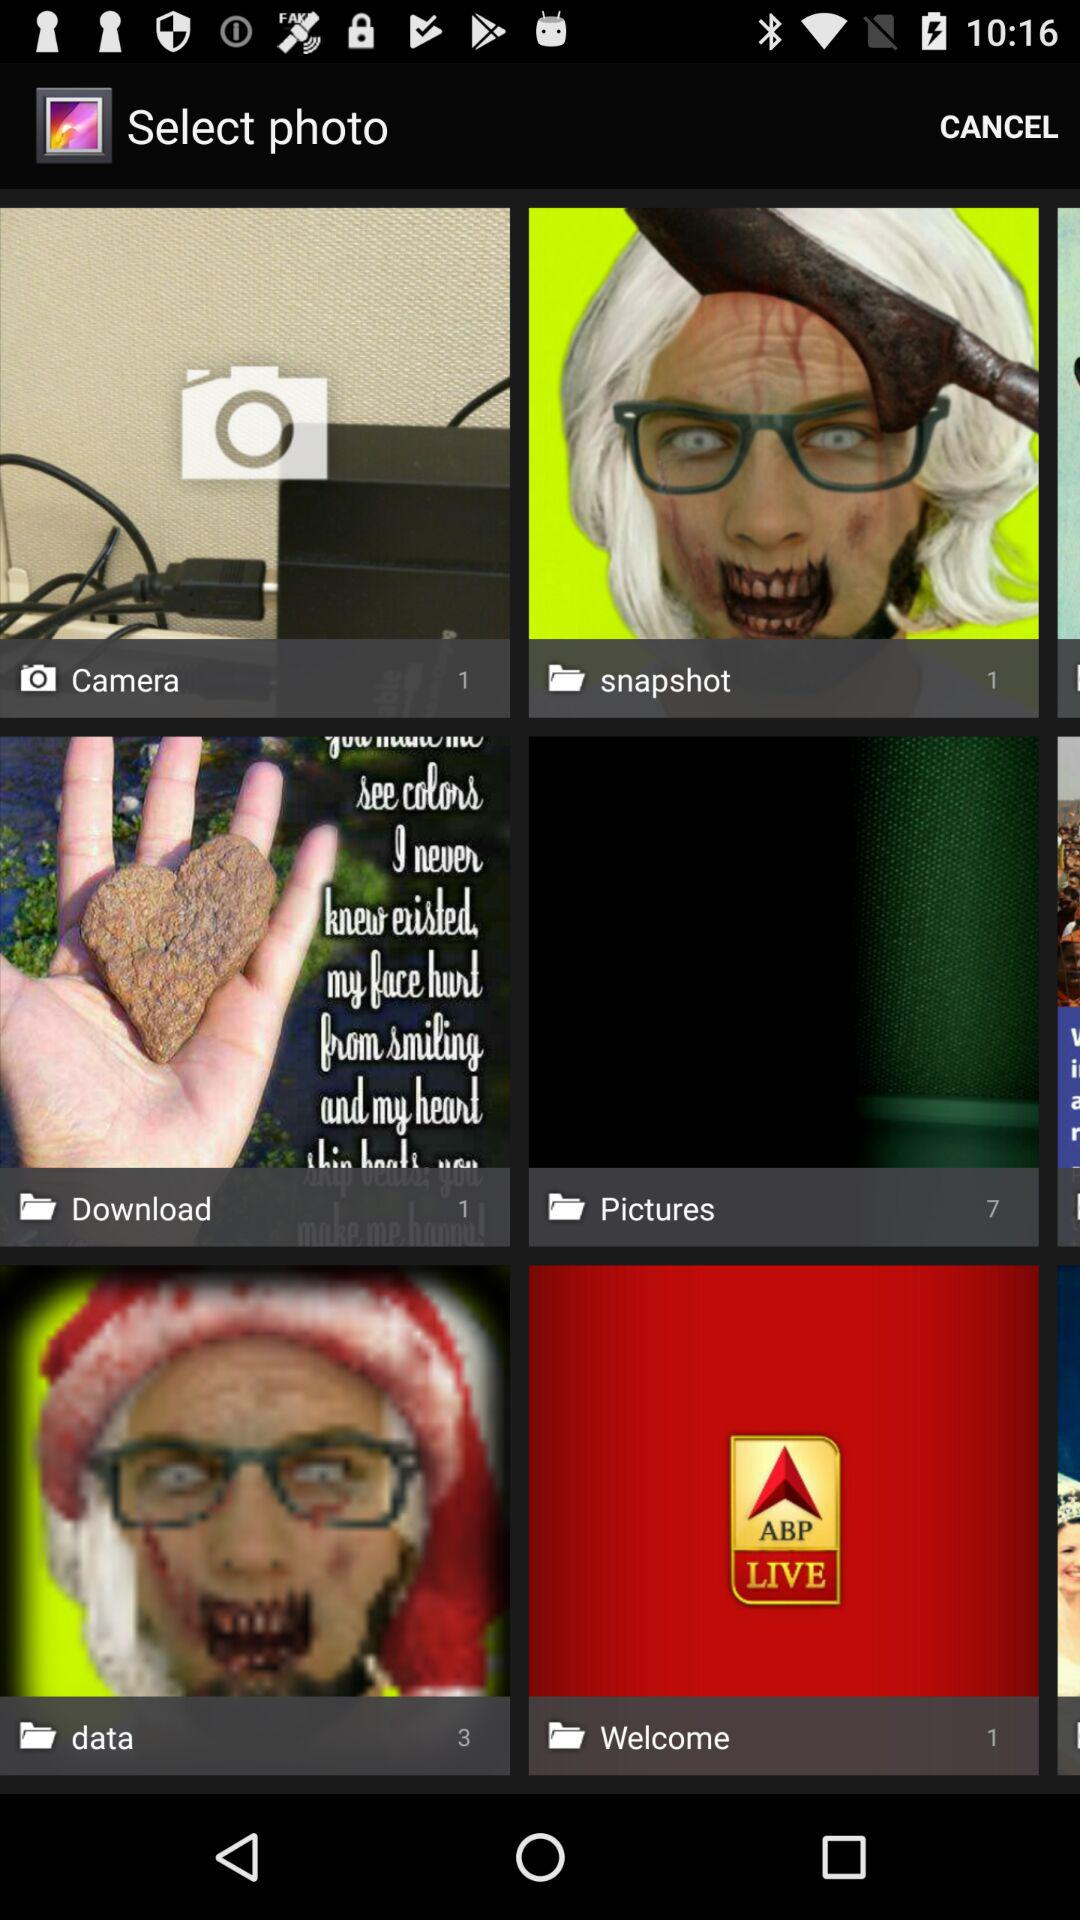How many pictures are in the camera folder? The picture in the camera folder is 1. 